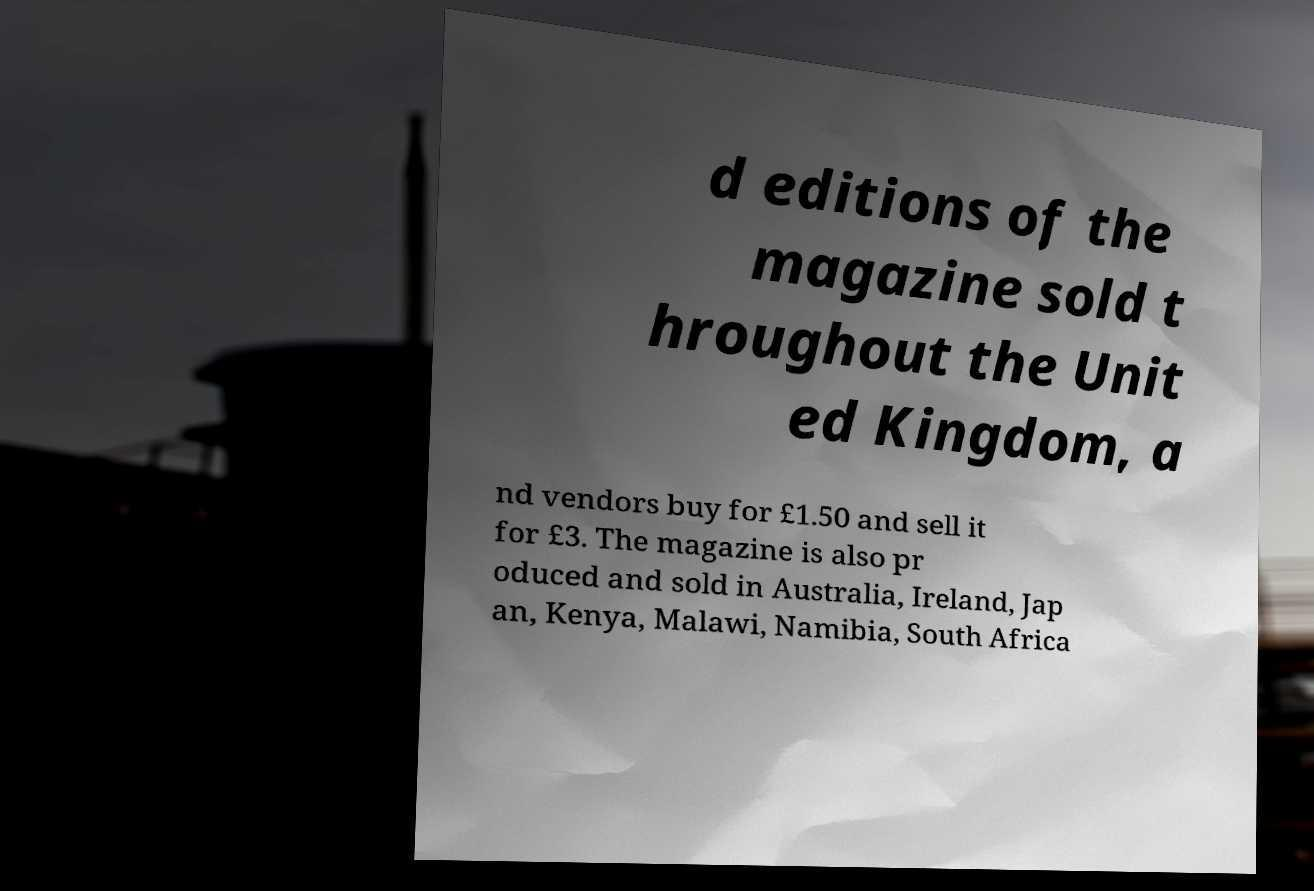Could you extract and type out the text from this image? d editions of the magazine sold t hroughout the Unit ed Kingdom, a nd vendors buy for £1.50 and sell it for £3. The magazine is also pr oduced and sold in Australia, Ireland, Jap an, Kenya, Malawi, Namibia, South Africa 